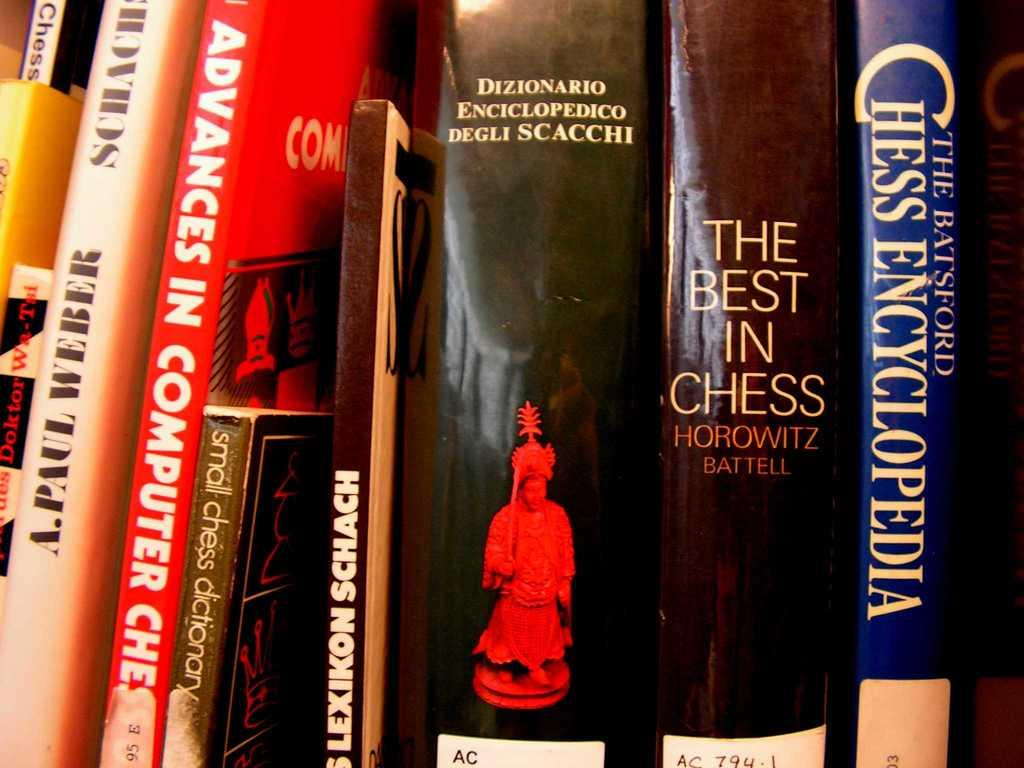Provide a one-sentence caption for the provided image. A book collection which includes the best in chess, and advances in computer chess among others. 